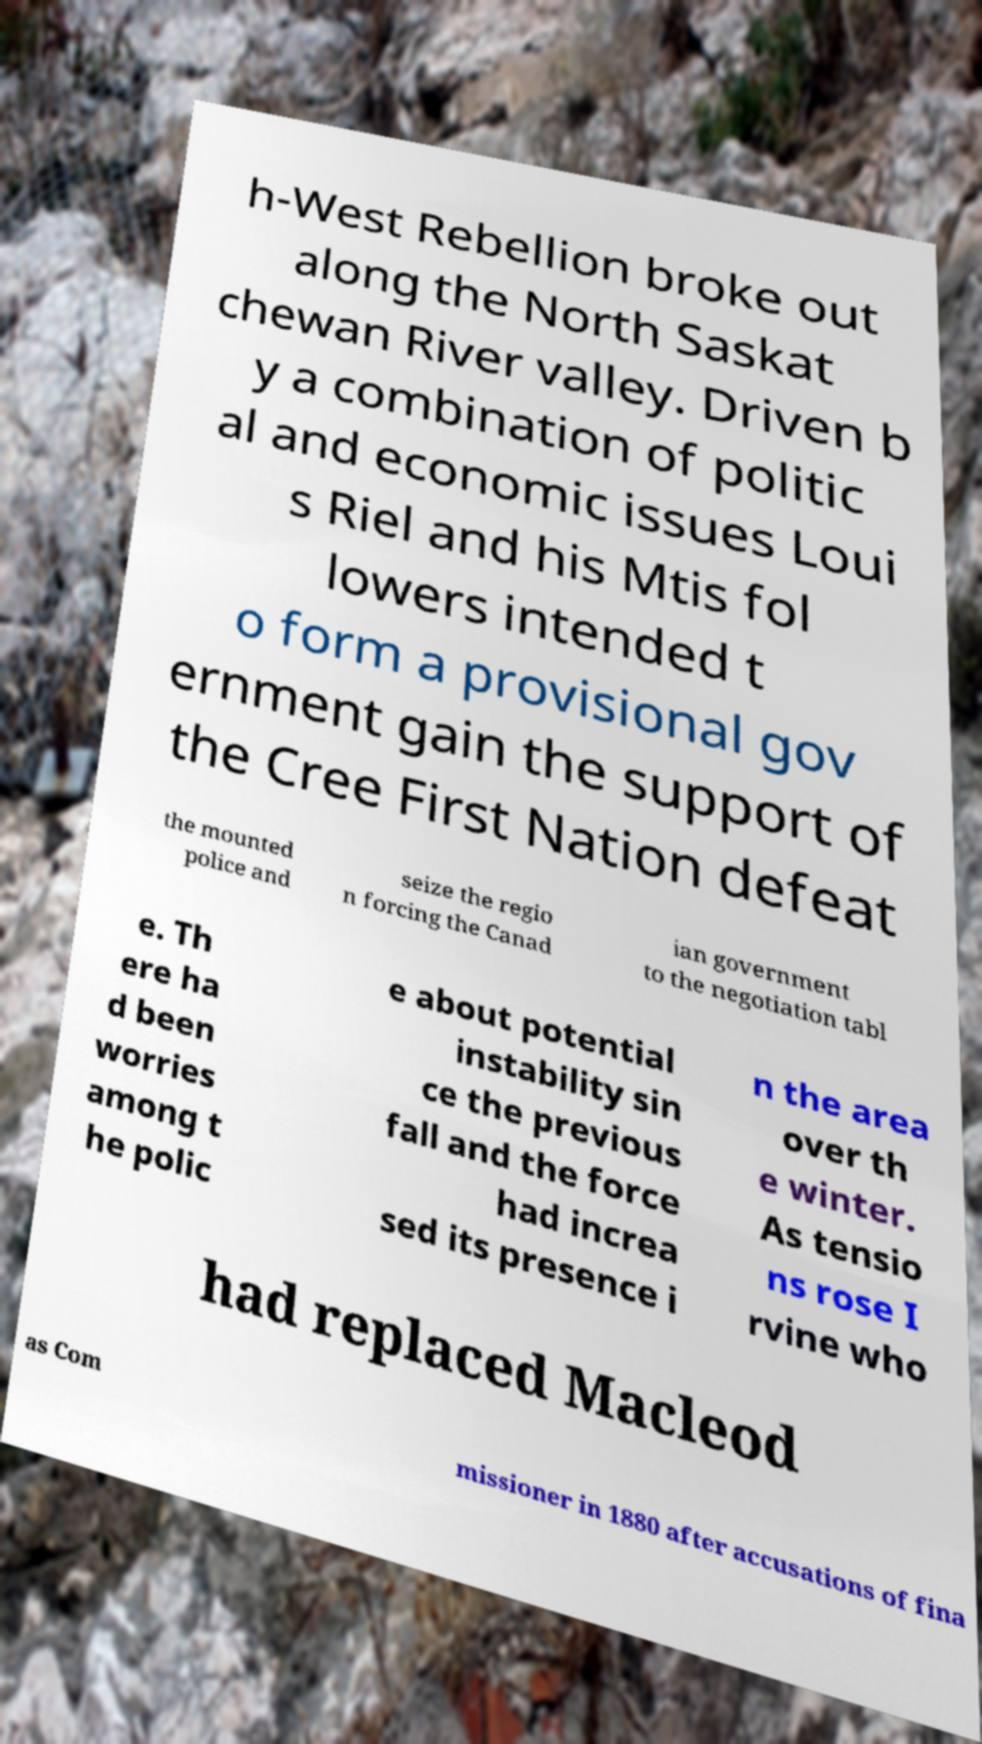What messages or text are displayed in this image? I need them in a readable, typed format. h-West Rebellion broke out along the North Saskat chewan River valley. Driven b y a combination of politic al and economic issues Loui s Riel and his Mtis fol lowers intended t o form a provisional gov ernment gain the support of the Cree First Nation defeat the mounted police and seize the regio n forcing the Canad ian government to the negotiation tabl e. Th ere ha d been worries among t he polic e about potential instability sin ce the previous fall and the force had increa sed its presence i n the area over th e winter. As tensio ns rose I rvine who had replaced Macleod as Com missioner in 1880 after accusations of fina 